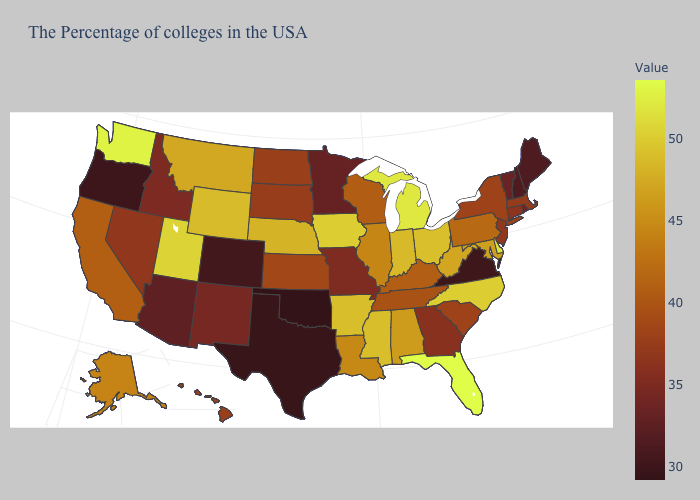Among the states that border New Hampshire , does Vermont have the highest value?
Be succinct. No. Is the legend a continuous bar?
Short answer required. Yes. Does Wyoming have a lower value than Delaware?
Concise answer only. Yes. Which states have the lowest value in the Northeast?
Write a very short answer. Maine, New Hampshire. Which states have the lowest value in the West?
Keep it brief. Oregon. Is the legend a continuous bar?
Concise answer only. Yes. Which states have the lowest value in the USA?
Be succinct. Oklahoma. Which states have the lowest value in the South?
Short answer required. Oklahoma. Among the states that border Utah , which have the highest value?
Concise answer only. Wyoming. 